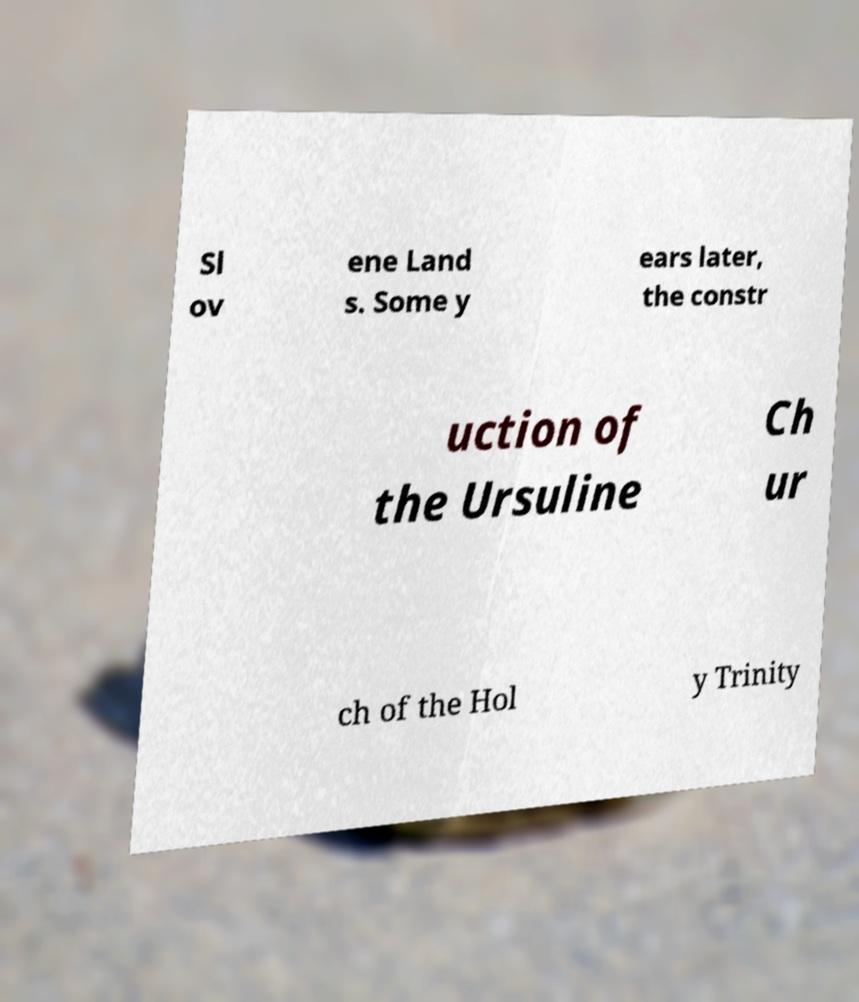For documentation purposes, I need the text within this image transcribed. Could you provide that? Sl ov ene Land s. Some y ears later, the constr uction of the Ursuline Ch ur ch of the Hol y Trinity 